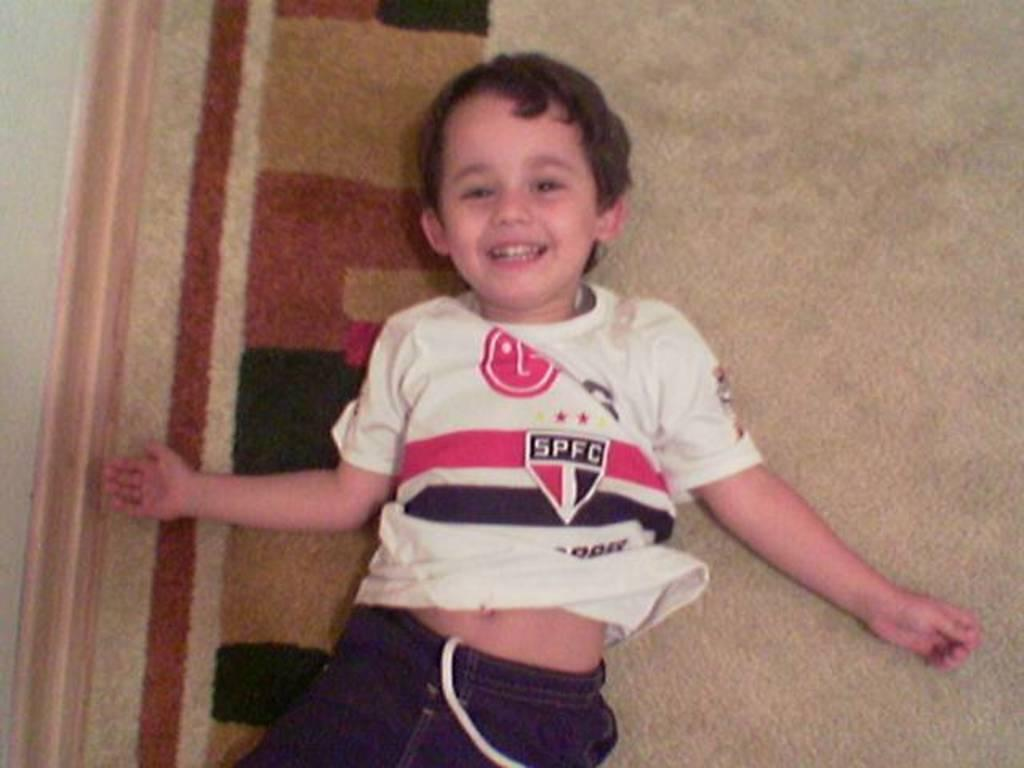<image>
Give a short and clear explanation of the subsequent image. A young boy wears a shirt with the name SPFC. 